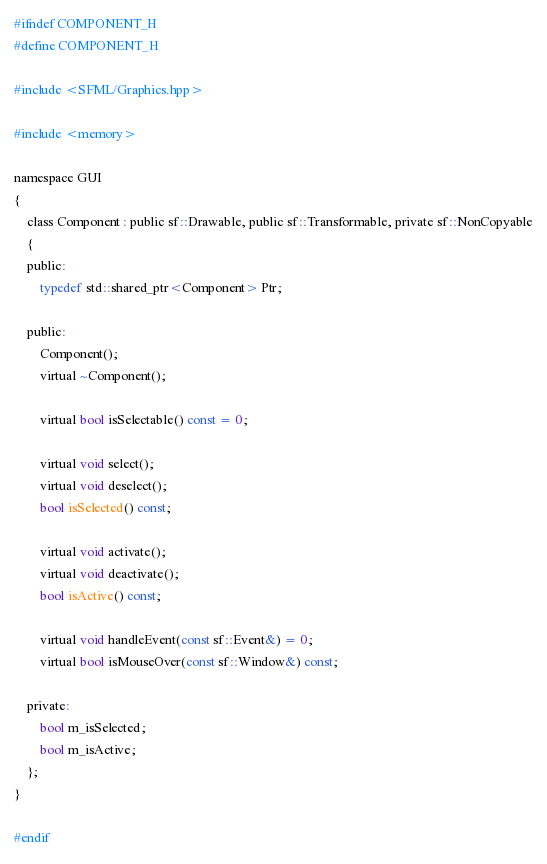Convert code to text. <code><loc_0><loc_0><loc_500><loc_500><_C_>#ifndef COMPONENT_H 
#define COMPONENT_H

#include <SFML/Graphics.hpp>

#include <memory>

namespace GUI
{
    class Component : public sf::Drawable, public sf::Transformable, private sf::NonCopyable
    {
    public:
        typedef std::shared_ptr<Component> Ptr;

    public:
        Component();
        virtual ~Component();

        virtual bool isSelectable() const = 0;

        virtual void select();
        virtual void deselect();
        bool isSelected() const;

        virtual void activate();
        virtual void deactivate();
        bool isActive() const;

        virtual void handleEvent(const sf::Event&) = 0;
        virtual bool isMouseOver(const sf::Window&) const;

    private:
        bool m_isSelected;
        bool m_isActive;
    };
}

#endif</code> 